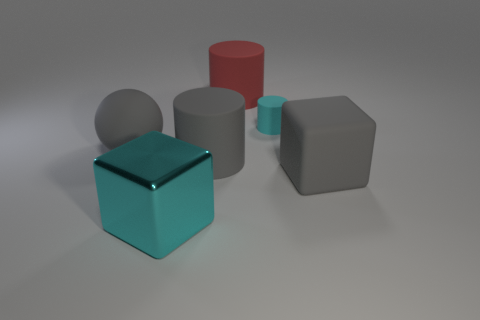Is there any other thing that is made of the same material as the cyan block?
Offer a very short reply. No. Does the matte block have the same color as the matte sphere?
Ensure brevity in your answer.  Yes. Do the large cylinder that is in front of the cyan matte cylinder and the large matte cube have the same color?
Give a very brief answer. Yes. Are there any large cubes that have the same color as the matte ball?
Your answer should be compact. Yes. There is a cylinder that is the same color as the large shiny thing; what size is it?
Ensure brevity in your answer.  Small. There is a large metal object that is in front of the small cylinder; is its color the same as the rubber cylinder to the right of the large red matte object?
Make the answer very short. Yes. How many other objects are there of the same shape as the big red object?
Make the answer very short. 2. Are there any blocks that have the same material as the sphere?
Your response must be concise. Yes. Does the cylinder that is in front of the large rubber ball have the same material as the large gray block that is in front of the big gray cylinder?
Provide a short and direct response. Yes. How many big gray cubes are there?
Offer a very short reply. 1. 